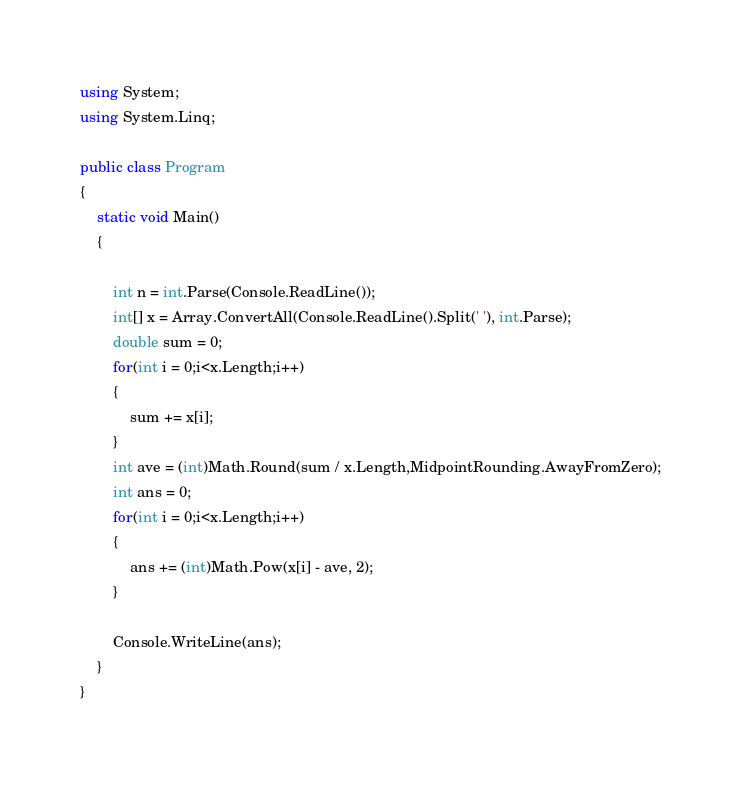<code> <loc_0><loc_0><loc_500><loc_500><_C#_>using System;
using System.Linq;

public class Program
{
    static void Main()
    {

        int n = int.Parse(Console.ReadLine());
        int[] x = Array.ConvertAll(Console.ReadLine().Split(' '), int.Parse);
        double sum = 0;
        for(int i = 0;i<x.Length;i++)
        {
            sum += x[i];
        }
        int ave = (int)Math.Round(sum / x.Length,MidpointRounding.AwayFromZero);
        int ans = 0;
        for(int i = 0;i<x.Length;i++)
        {
            ans += (int)Math.Pow(x[i] - ave, 2);
        }

        Console.WriteLine(ans);
    }
}</code> 